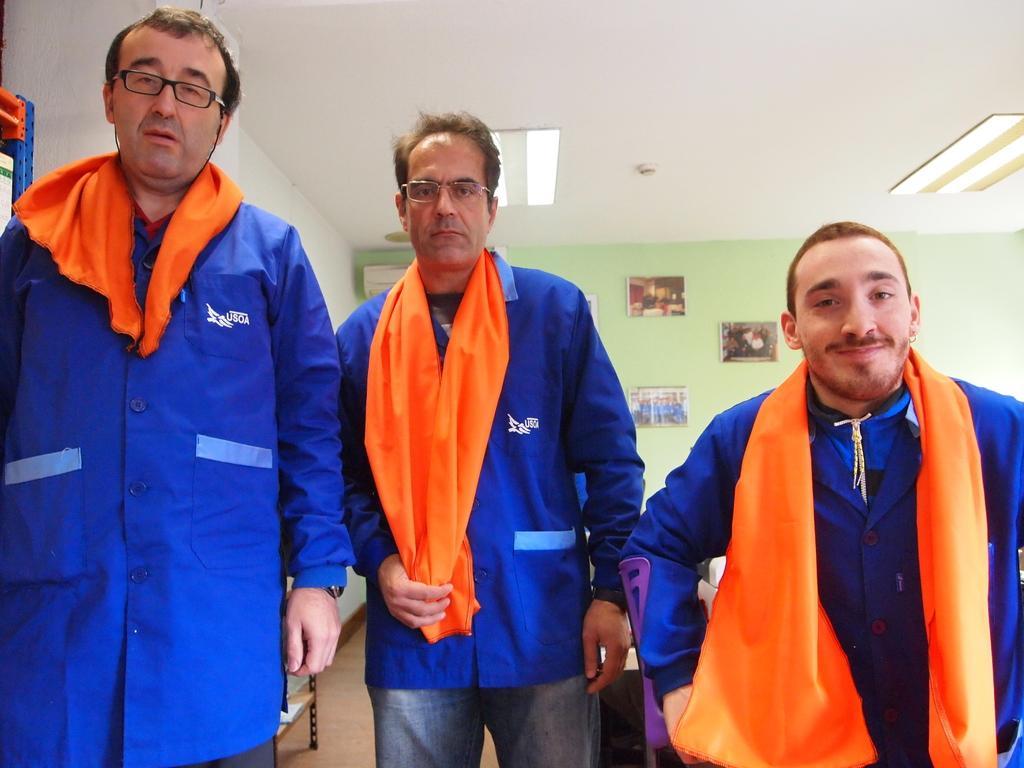Please provide a concise description of this image. In this image we can these three people are wearing blue shirts and orange color clothes on them are standing on the floor. In the background, we can see photo frames on the wall and lights on the ceiling. 